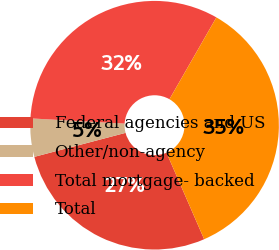Convert chart to OTSL. <chart><loc_0><loc_0><loc_500><loc_500><pie_chart><fcel>Federal agencies and US<fcel>Other/non-agency<fcel>Total mortgage- backed<fcel>Total<nl><fcel>27.44%<fcel>4.97%<fcel>32.41%<fcel>35.18%<nl></chart> 